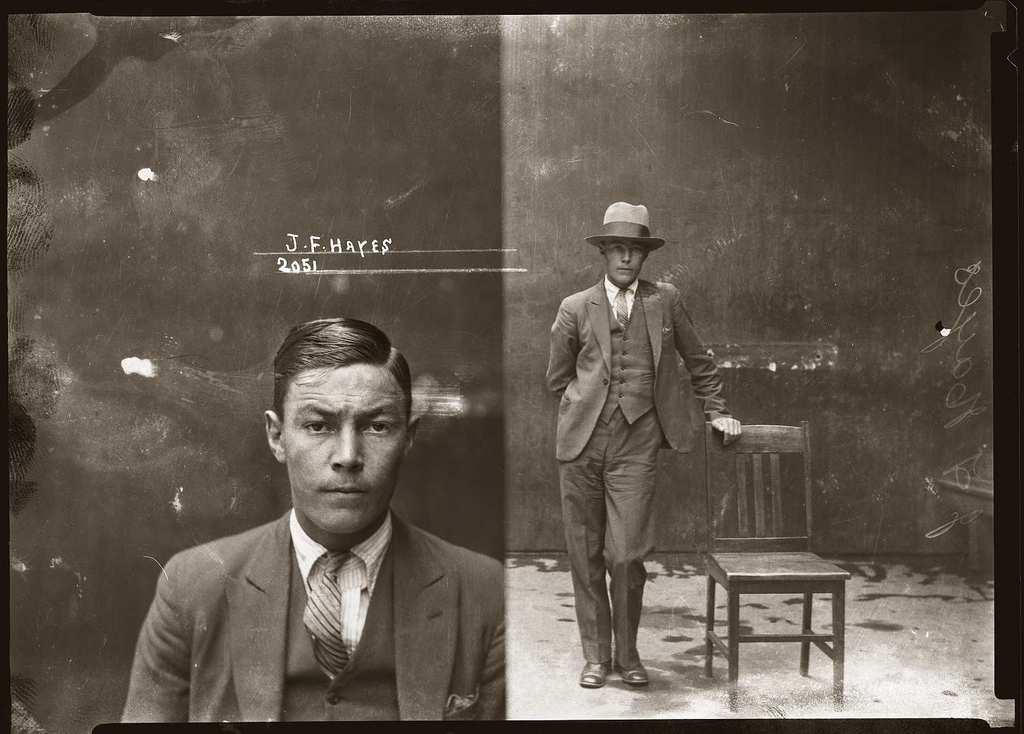Please provide a concise description of this image. I see this is a collage image and I see 2 men who are wearing suits and this man is wearing hat on his head and I see that there is a chair over here and I see the floor and I see something is written over here. 